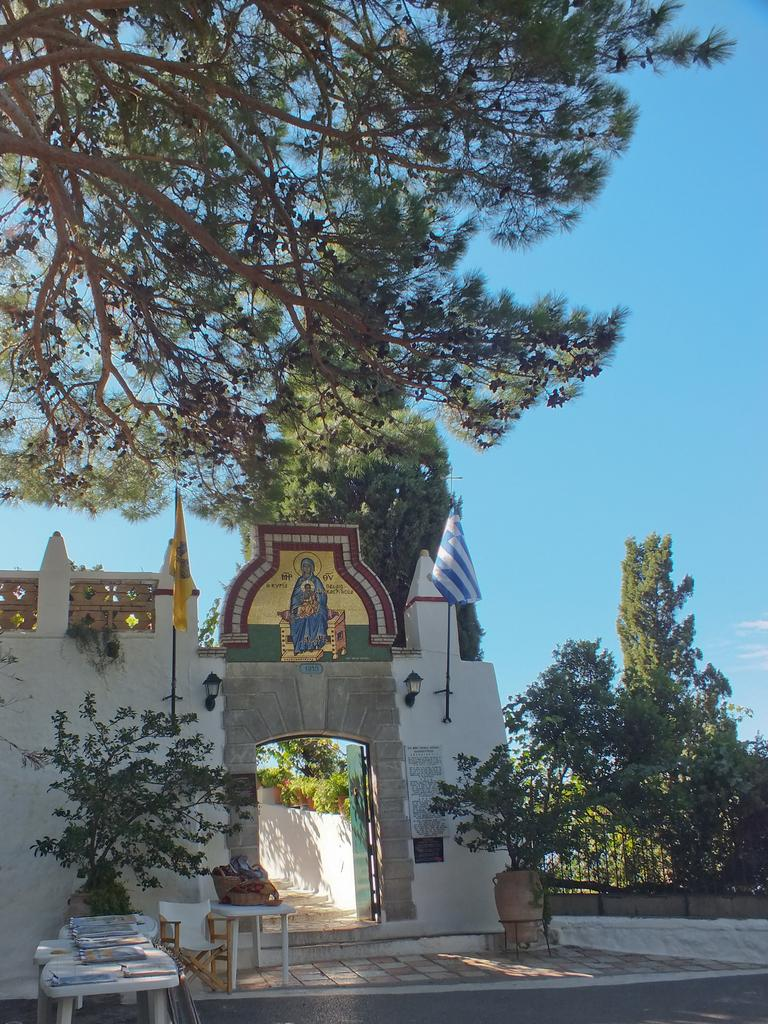What type of building can be seen in the image? There is an entrance to a church in the image. What decorative elements are present on the walls? Flags are present on the walls. What natural elements can be seen in the image? Plants and trees are visible in the image. What type of furniture is present in the image? There are tables present. How many passengers are waiting at the dock in the image? There is no dock or passengers present in the image. What type of balls are being used for the game in the image? There is no game or balls present in the image. 